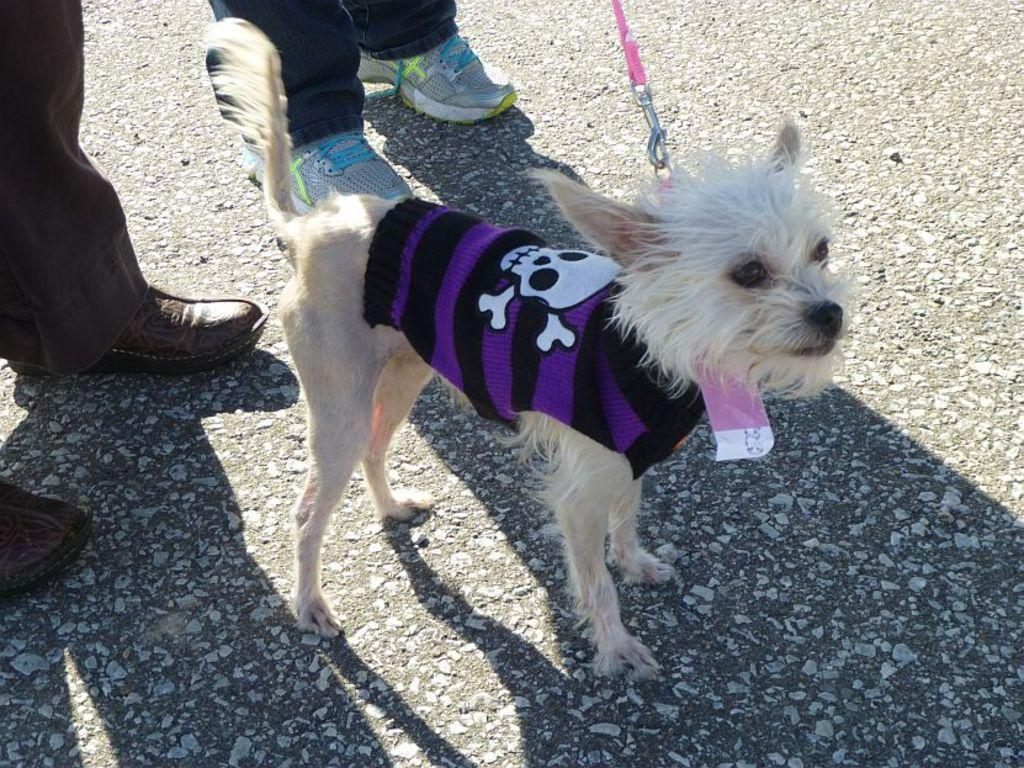What type of animal is present in the image? There is a dog in the image. Can you describe any other elements in the image? Yes, there are people's legs with shoes visible in the image. What type of tank is visible on the side of the page in the image? There is no tank or page present in the image; it only features a dog and people's legs with shoes. 